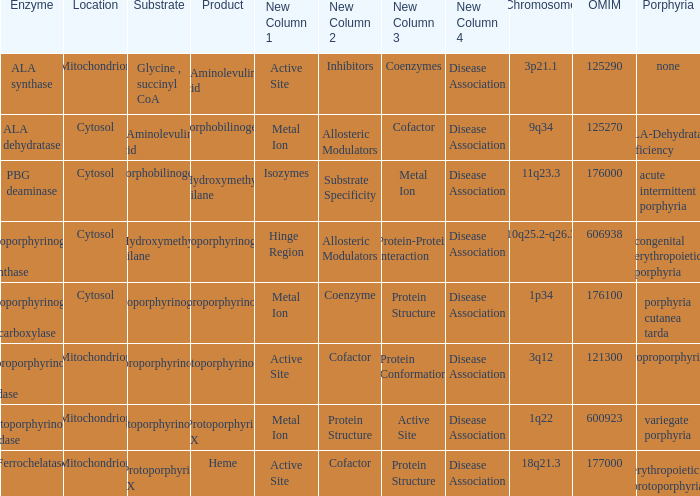What is protoporphyrin ix's substrate? Protoporphyrinogen IX. Parse the full table. {'header': ['Enzyme', 'Location', 'Substrate', 'Product', 'New Column 1', 'New Column 2', 'New Column 3', 'New Column 4', 'Chromosome', 'OMIM', 'Porphyria'], 'rows': [['ALA synthase', 'Mitochondrion', 'Glycine , succinyl CoA', 'δ-Aminolevulinic acid', 'Active Site', 'Inhibitors', 'Coenzymes', 'Disease Association', '3p21.1', '125290', 'none'], ['ALA dehydratase', 'Cytosol', 'δ-Aminolevulinic acid', 'Porphobilinogen', 'Metal Ion', 'Allosteric Modulators', 'Cofactor', 'Disease Association', '9q34', '125270', 'ALA-Dehydratase deficiency'], ['PBG deaminase', 'Cytosol', 'Porphobilinogen', 'Hydroxymethyl bilane', 'Isozymes', 'Substrate Specificity', 'Metal Ion', 'Disease Association', '11q23.3', '176000', 'acute intermittent porphyria'], ['Uroporphyrinogen III synthase', 'Cytosol', 'Hydroxymethyl bilane', 'Uroporphyrinogen III', 'Hinge Region', 'Allosteric Modulators', 'Protein-Protein Interaction', 'Disease Association', '10q25.2-q26.3', '606938', 'congenital erythropoietic porphyria'], ['Uroporphyrinogen III decarboxylase', 'Cytosol', 'Uroporphyrinogen III', 'Coproporphyrinogen III', 'Metal Ion', 'Coenzyme', 'Protein Structure', 'Disease Association', '1p34', '176100', 'porphyria cutanea tarda'], ['Coproporphyrinogen III oxidase', 'Mitochondrion', 'Coproporphyrinogen III', 'Protoporphyrinogen IX', 'Active Site', 'Cofactor', 'Protein Conformation', 'Disease Association', '3q12', '121300', 'coproporphyria'], ['Protoporphyrinogen oxidase', 'Mitochondrion', 'Protoporphyrinogen IX', 'Protoporphyrin IX', 'Metal Ion', 'Protein Structure', 'Active Site', 'Disease Association', '1q22', '600923', 'variegate porphyria'], ['Ferrochelatase', 'Mitochondrion', 'Protoporphyrin IX', 'Heme', 'Active Site', 'Cofactor', 'Protein Structure', 'Disease Association', '18q21.3', '177000', 'erythropoietic protoporphyria']]} 